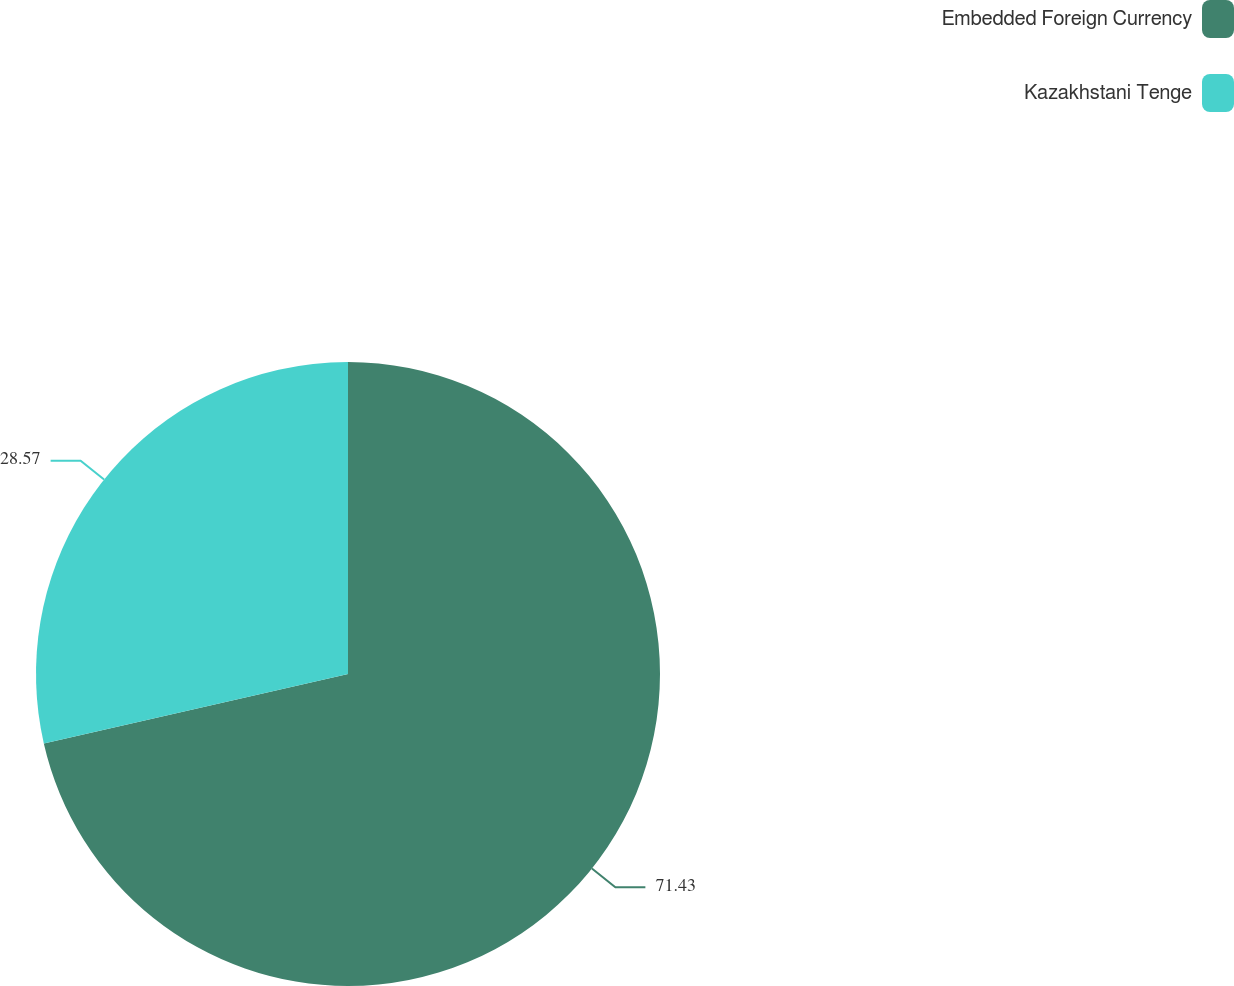Convert chart. <chart><loc_0><loc_0><loc_500><loc_500><pie_chart><fcel>Embedded Foreign Currency<fcel>Kazakhstani Tenge<nl><fcel>71.43%<fcel>28.57%<nl></chart> 